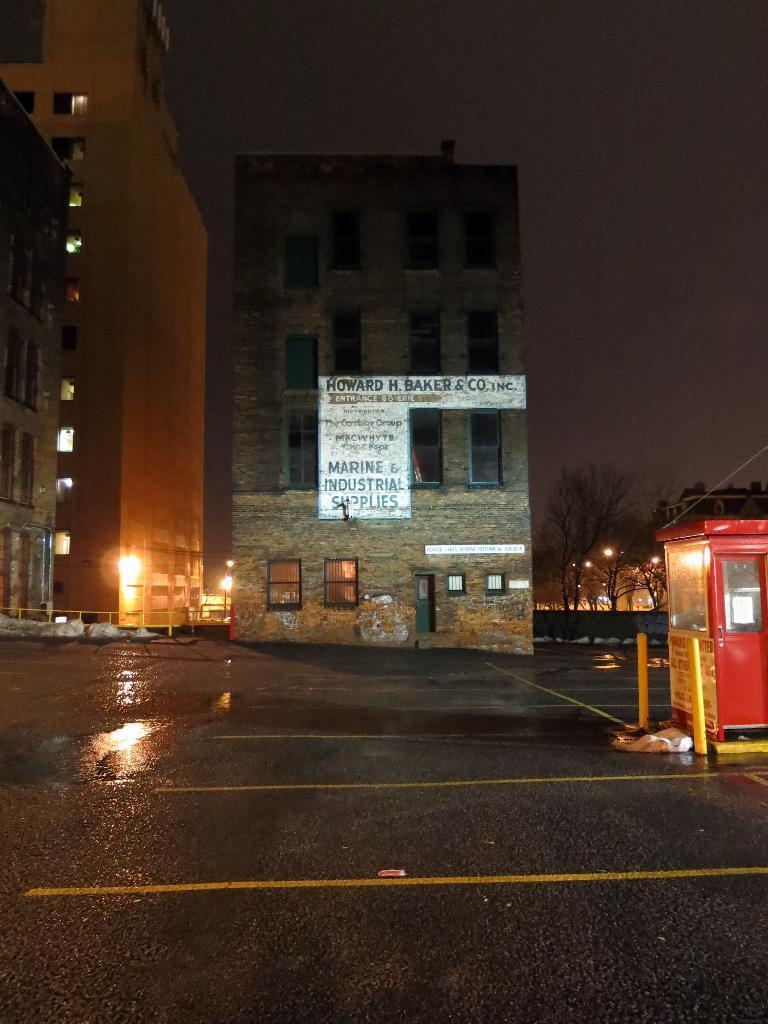Describe this image in one or two sentences. In this image we can see few buildings and they are having many windows. We can see the sky. There is a reflection of light on the road. There are many trees in the image. There is a board in the image. There are few lights in the image. 